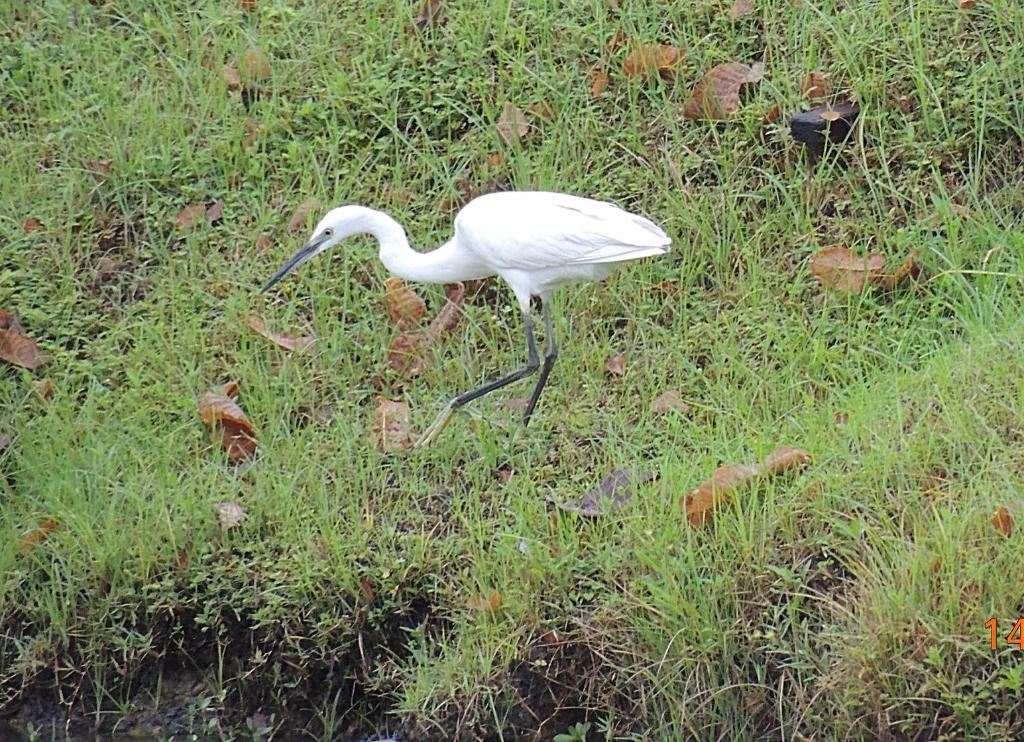What is the main subject of the image? There is a crane in the image. Where is the crane located? The crane is on the ground. Which direction is the crane facing? The crane is facing towards the left side. What type of vegetation is present on the ground in the image? There is grass and leaves on the ground in the image. What type of cheese can be seen on the ground in the image? There is no cheese present in the image; it features a crane on the ground with grass and leaves. How many birds are perched on the crane in the image? There are no birds present in the image; it only features a crane and vegetation on the ground. 